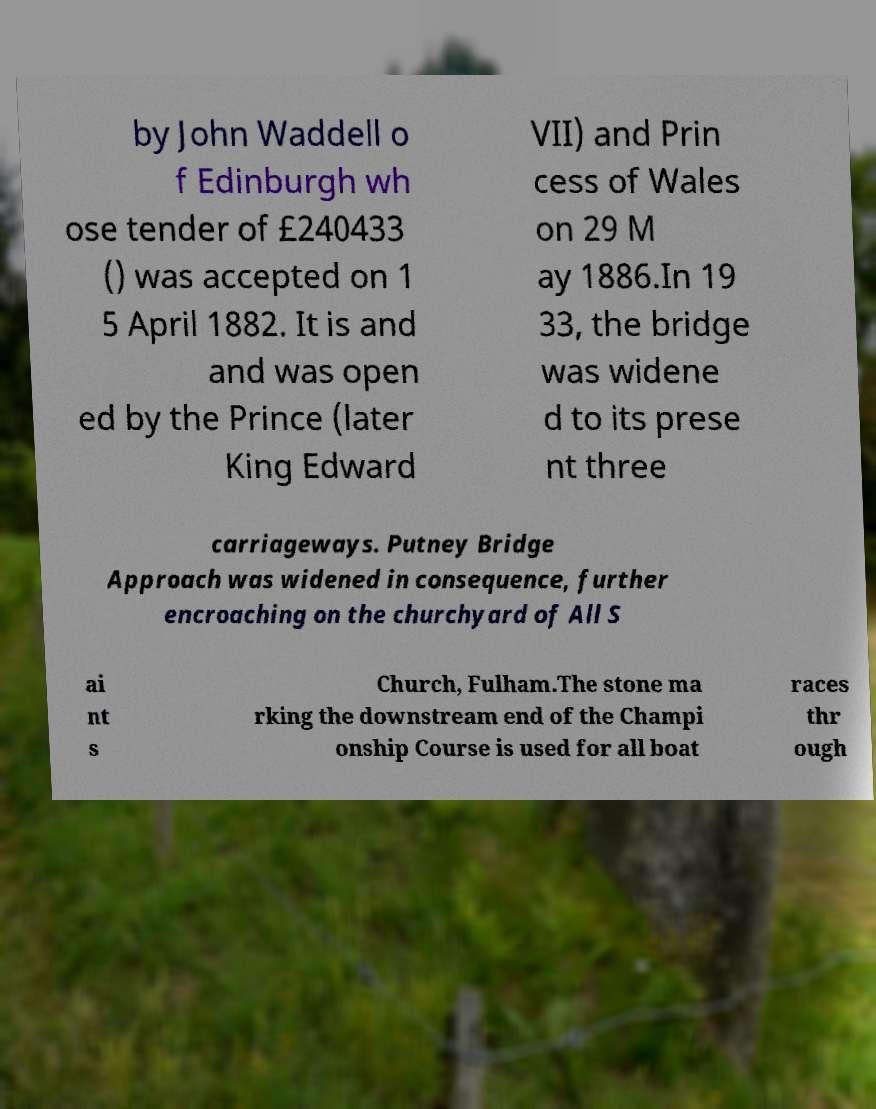Could you extract and type out the text from this image? by John Waddell o f Edinburgh wh ose tender of £240433 () was accepted on 1 5 April 1882. It is and and was open ed by the Prince (later King Edward VII) and Prin cess of Wales on 29 M ay 1886.In 19 33, the bridge was widene d to its prese nt three carriageways. Putney Bridge Approach was widened in consequence, further encroaching on the churchyard of All S ai nt s Church, Fulham.The stone ma rking the downstream end of the Champi onship Course is used for all boat races thr ough 